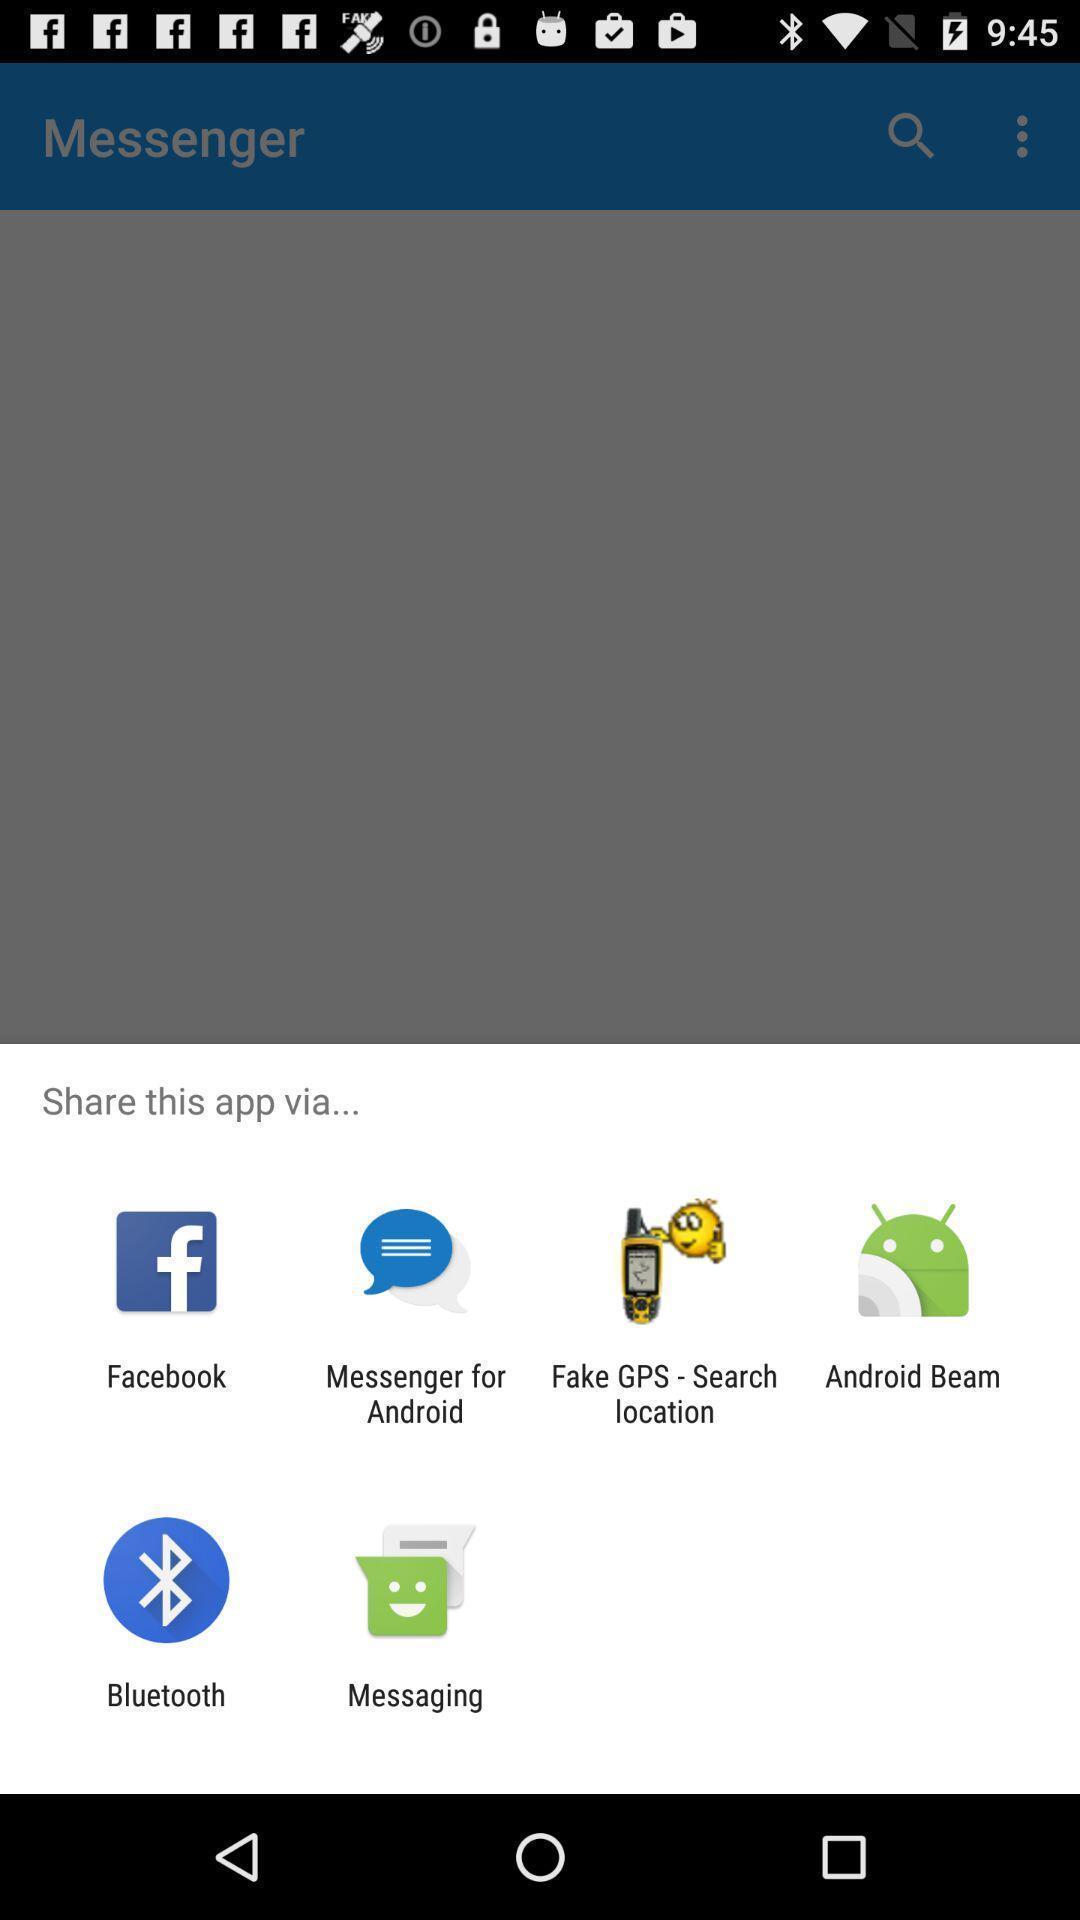Provide a detailed account of this screenshot. Pop-up showing multiple options to share the app. 